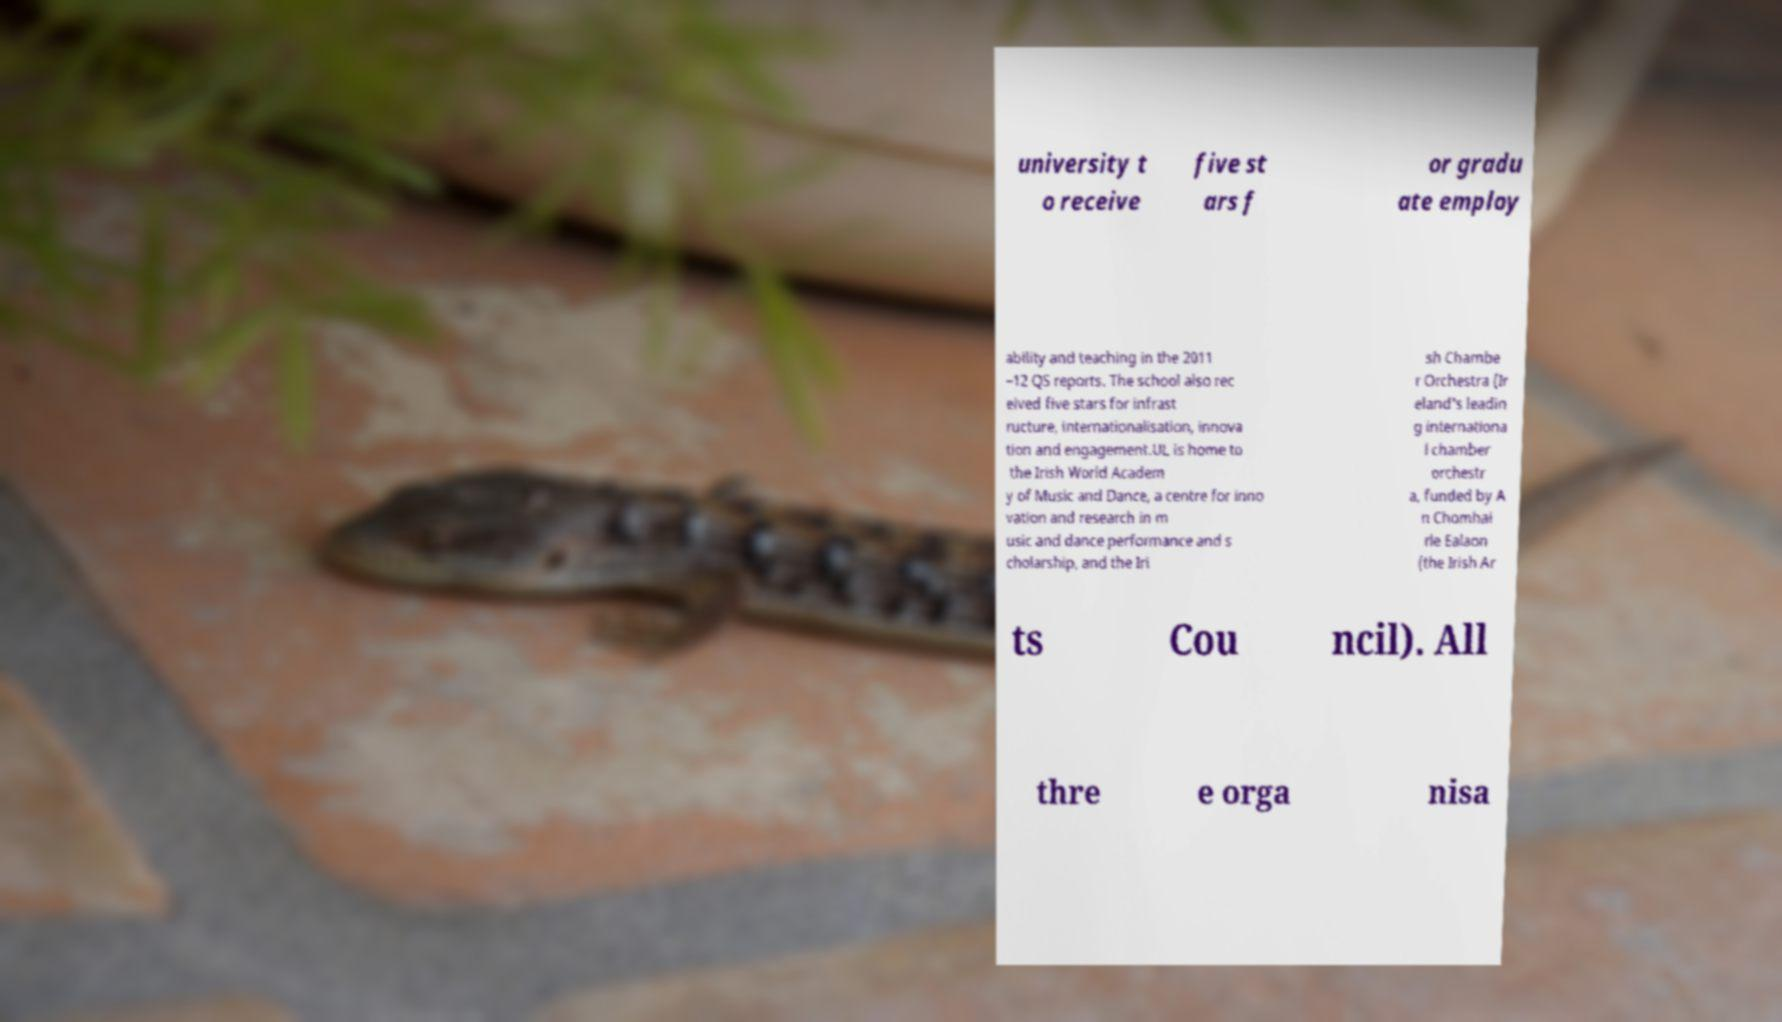Can you read and provide the text displayed in the image?This photo seems to have some interesting text. Can you extract and type it out for me? university t o receive five st ars f or gradu ate employ ability and teaching in the 2011 –12 QS reports. The school also rec eived five stars for infrast ructure, internationalisation, innova tion and engagement.UL is home to the Irish World Academ y of Music and Dance, a centre for inno vation and research in m usic and dance performance and s cholarship, and the Iri sh Chambe r Orchestra (Ir eland's leadin g internationa l chamber orchestr a, funded by A n Chomhai rle Ealaon (the Irish Ar ts Cou ncil). All thre e orga nisa 